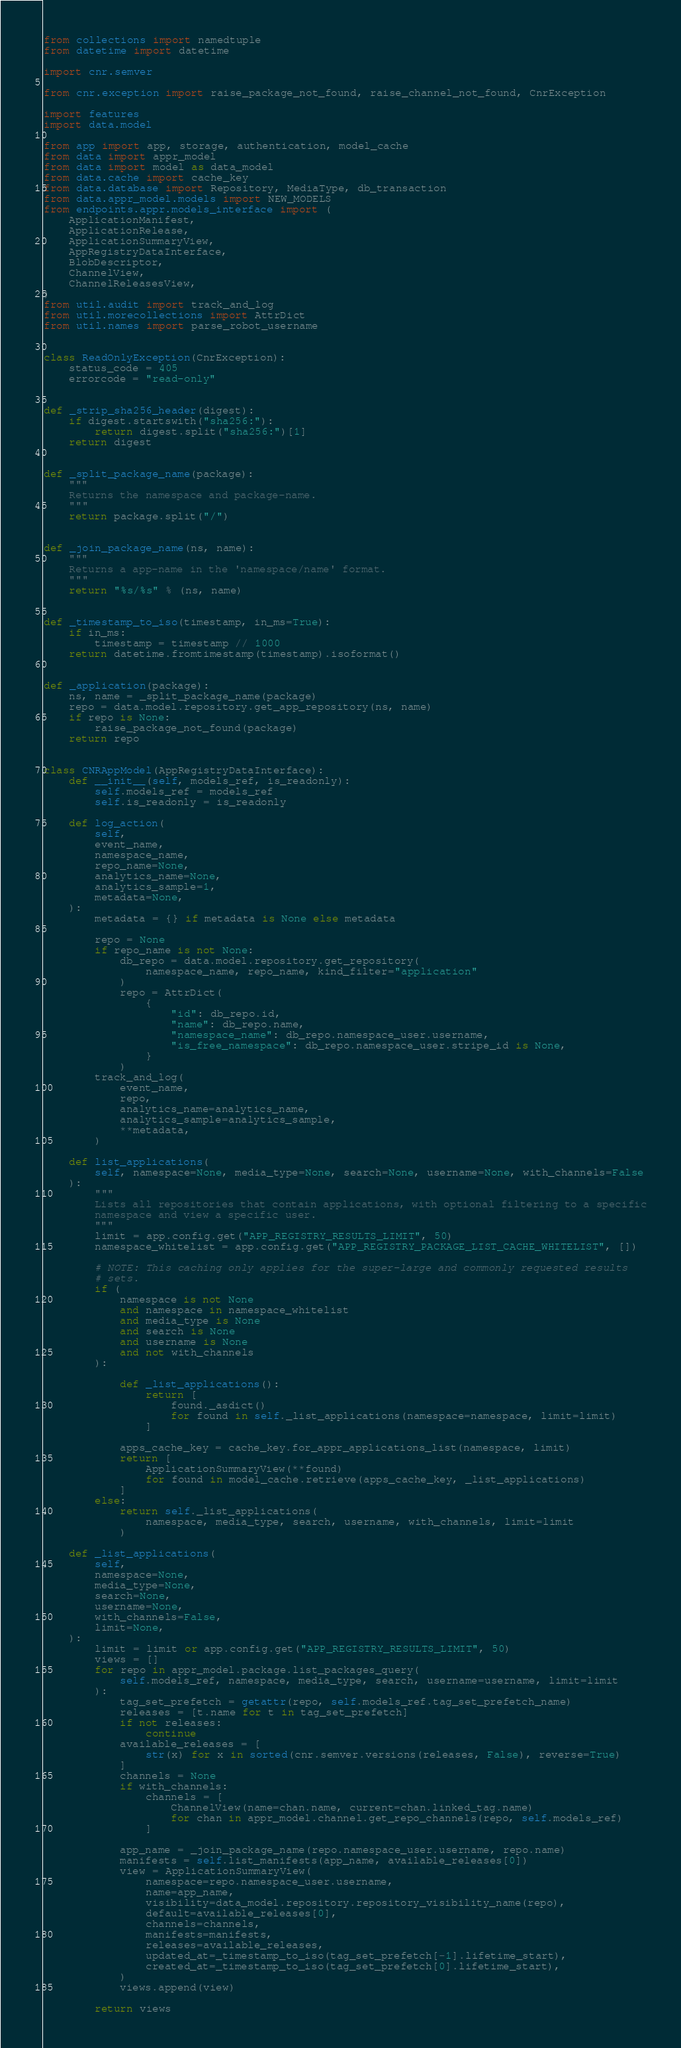Convert code to text. <code><loc_0><loc_0><loc_500><loc_500><_Python_>from collections import namedtuple
from datetime import datetime

import cnr.semver

from cnr.exception import raise_package_not_found, raise_channel_not_found, CnrException

import features
import data.model

from app import app, storage, authentication, model_cache
from data import appr_model
from data import model as data_model
from data.cache import cache_key
from data.database import Repository, MediaType, db_transaction
from data.appr_model.models import NEW_MODELS
from endpoints.appr.models_interface import (
    ApplicationManifest,
    ApplicationRelease,
    ApplicationSummaryView,
    AppRegistryDataInterface,
    BlobDescriptor,
    ChannelView,
    ChannelReleasesView,
)
from util.audit import track_and_log
from util.morecollections import AttrDict
from util.names import parse_robot_username


class ReadOnlyException(CnrException):
    status_code = 405
    errorcode = "read-only"


def _strip_sha256_header(digest):
    if digest.startswith("sha256:"):
        return digest.split("sha256:")[1]
    return digest


def _split_package_name(package):
    """
    Returns the namespace and package-name.
    """
    return package.split("/")


def _join_package_name(ns, name):
    """
    Returns a app-name in the 'namespace/name' format.
    """
    return "%s/%s" % (ns, name)


def _timestamp_to_iso(timestamp, in_ms=True):
    if in_ms:
        timestamp = timestamp // 1000
    return datetime.fromtimestamp(timestamp).isoformat()


def _application(package):
    ns, name = _split_package_name(package)
    repo = data.model.repository.get_app_repository(ns, name)
    if repo is None:
        raise_package_not_found(package)
    return repo


class CNRAppModel(AppRegistryDataInterface):
    def __init__(self, models_ref, is_readonly):
        self.models_ref = models_ref
        self.is_readonly = is_readonly

    def log_action(
        self,
        event_name,
        namespace_name,
        repo_name=None,
        analytics_name=None,
        analytics_sample=1,
        metadata=None,
    ):
        metadata = {} if metadata is None else metadata

        repo = None
        if repo_name is not None:
            db_repo = data.model.repository.get_repository(
                namespace_name, repo_name, kind_filter="application"
            )
            repo = AttrDict(
                {
                    "id": db_repo.id,
                    "name": db_repo.name,
                    "namespace_name": db_repo.namespace_user.username,
                    "is_free_namespace": db_repo.namespace_user.stripe_id is None,
                }
            )
        track_and_log(
            event_name,
            repo,
            analytics_name=analytics_name,
            analytics_sample=analytics_sample,
            **metadata,
        )

    def list_applications(
        self, namespace=None, media_type=None, search=None, username=None, with_channels=False
    ):
        """
        Lists all repositories that contain applications, with optional filtering to a specific
        namespace and view a specific user.
        """
        limit = app.config.get("APP_REGISTRY_RESULTS_LIMIT", 50)
        namespace_whitelist = app.config.get("APP_REGISTRY_PACKAGE_LIST_CACHE_WHITELIST", [])

        # NOTE: This caching only applies for the super-large and commonly requested results
        # sets.
        if (
            namespace is not None
            and namespace in namespace_whitelist
            and media_type is None
            and search is None
            and username is None
            and not with_channels
        ):

            def _list_applications():
                return [
                    found._asdict()
                    for found in self._list_applications(namespace=namespace, limit=limit)
                ]

            apps_cache_key = cache_key.for_appr_applications_list(namespace, limit)
            return [
                ApplicationSummaryView(**found)
                for found in model_cache.retrieve(apps_cache_key, _list_applications)
            ]
        else:
            return self._list_applications(
                namespace, media_type, search, username, with_channels, limit=limit
            )

    def _list_applications(
        self,
        namespace=None,
        media_type=None,
        search=None,
        username=None,
        with_channels=False,
        limit=None,
    ):
        limit = limit or app.config.get("APP_REGISTRY_RESULTS_LIMIT", 50)
        views = []
        for repo in appr_model.package.list_packages_query(
            self.models_ref, namespace, media_type, search, username=username, limit=limit
        ):
            tag_set_prefetch = getattr(repo, self.models_ref.tag_set_prefetch_name)
            releases = [t.name for t in tag_set_prefetch]
            if not releases:
                continue
            available_releases = [
                str(x) for x in sorted(cnr.semver.versions(releases, False), reverse=True)
            ]
            channels = None
            if with_channels:
                channels = [
                    ChannelView(name=chan.name, current=chan.linked_tag.name)
                    for chan in appr_model.channel.get_repo_channels(repo, self.models_ref)
                ]

            app_name = _join_package_name(repo.namespace_user.username, repo.name)
            manifests = self.list_manifests(app_name, available_releases[0])
            view = ApplicationSummaryView(
                namespace=repo.namespace_user.username,
                name=app_name,
                visibility=data_model.repository.repository_visibility_name(repo),
                default=available_releases[0],
                channels=channels,
                manifests=manifests,
                releases=available_releases,
                updated_at=_timestamp_to_iso(tag_set_prefetch[-1].lifetime_start),
                created_at=_timestamp_to_iso(tag_set_prefetch[0].lifetime_start),
            )
            views.append(view)

        return views
</code> 